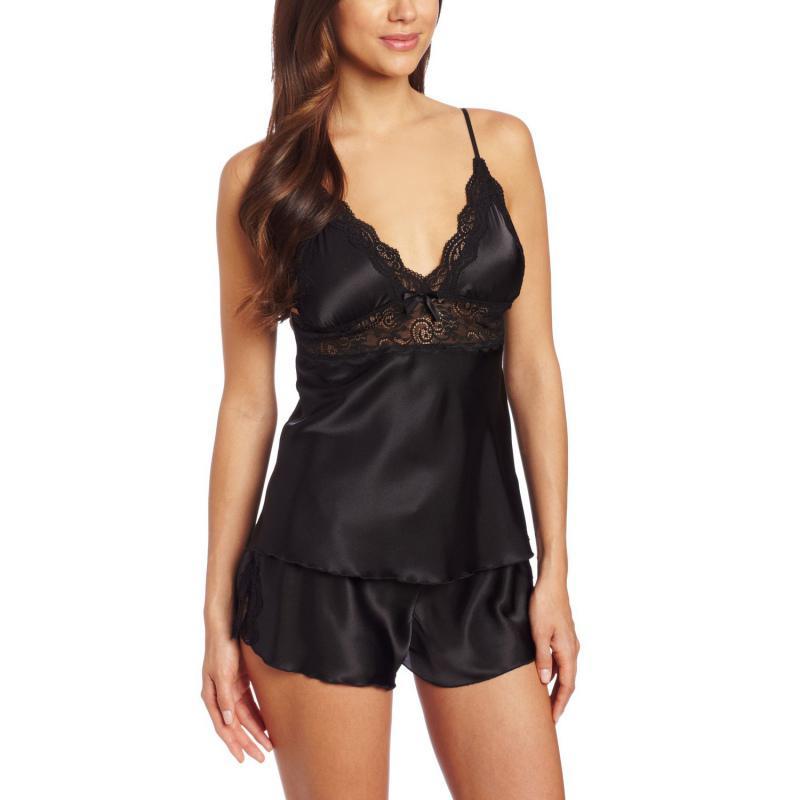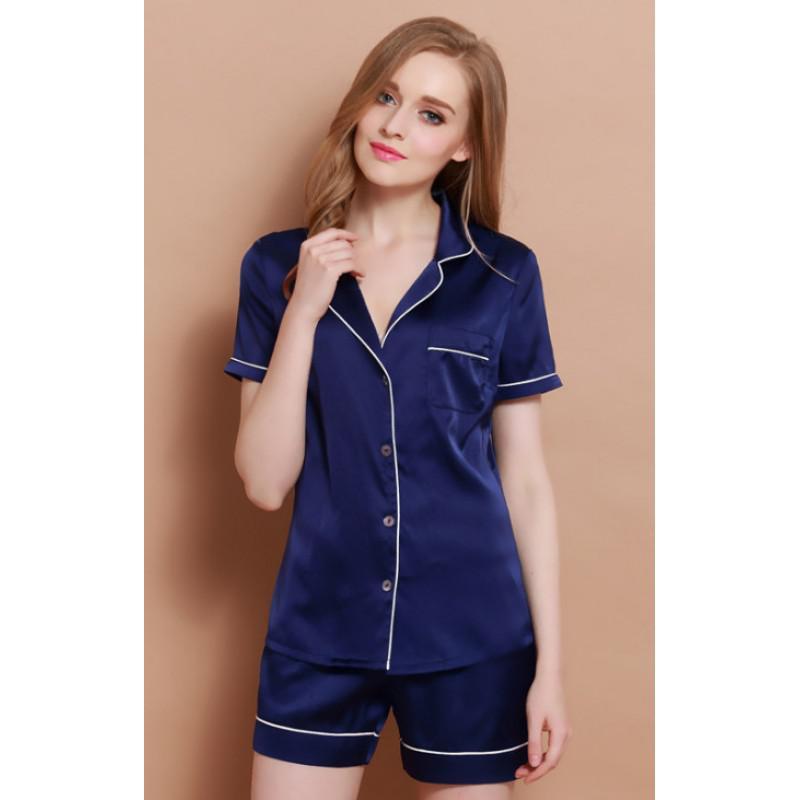The first image is the image on the left, the second image is the image on the right. For the images shown, is this caption "One image shows a women wearing a night gown with a robe." true? Answer yes or no. No. The first image is the image on the left, the second image is the image on the right. Assess this claim about the two images: "the pajamas have white piping accents around the pocket and shorts". Correct or not? Answer yes or no. Yes. 